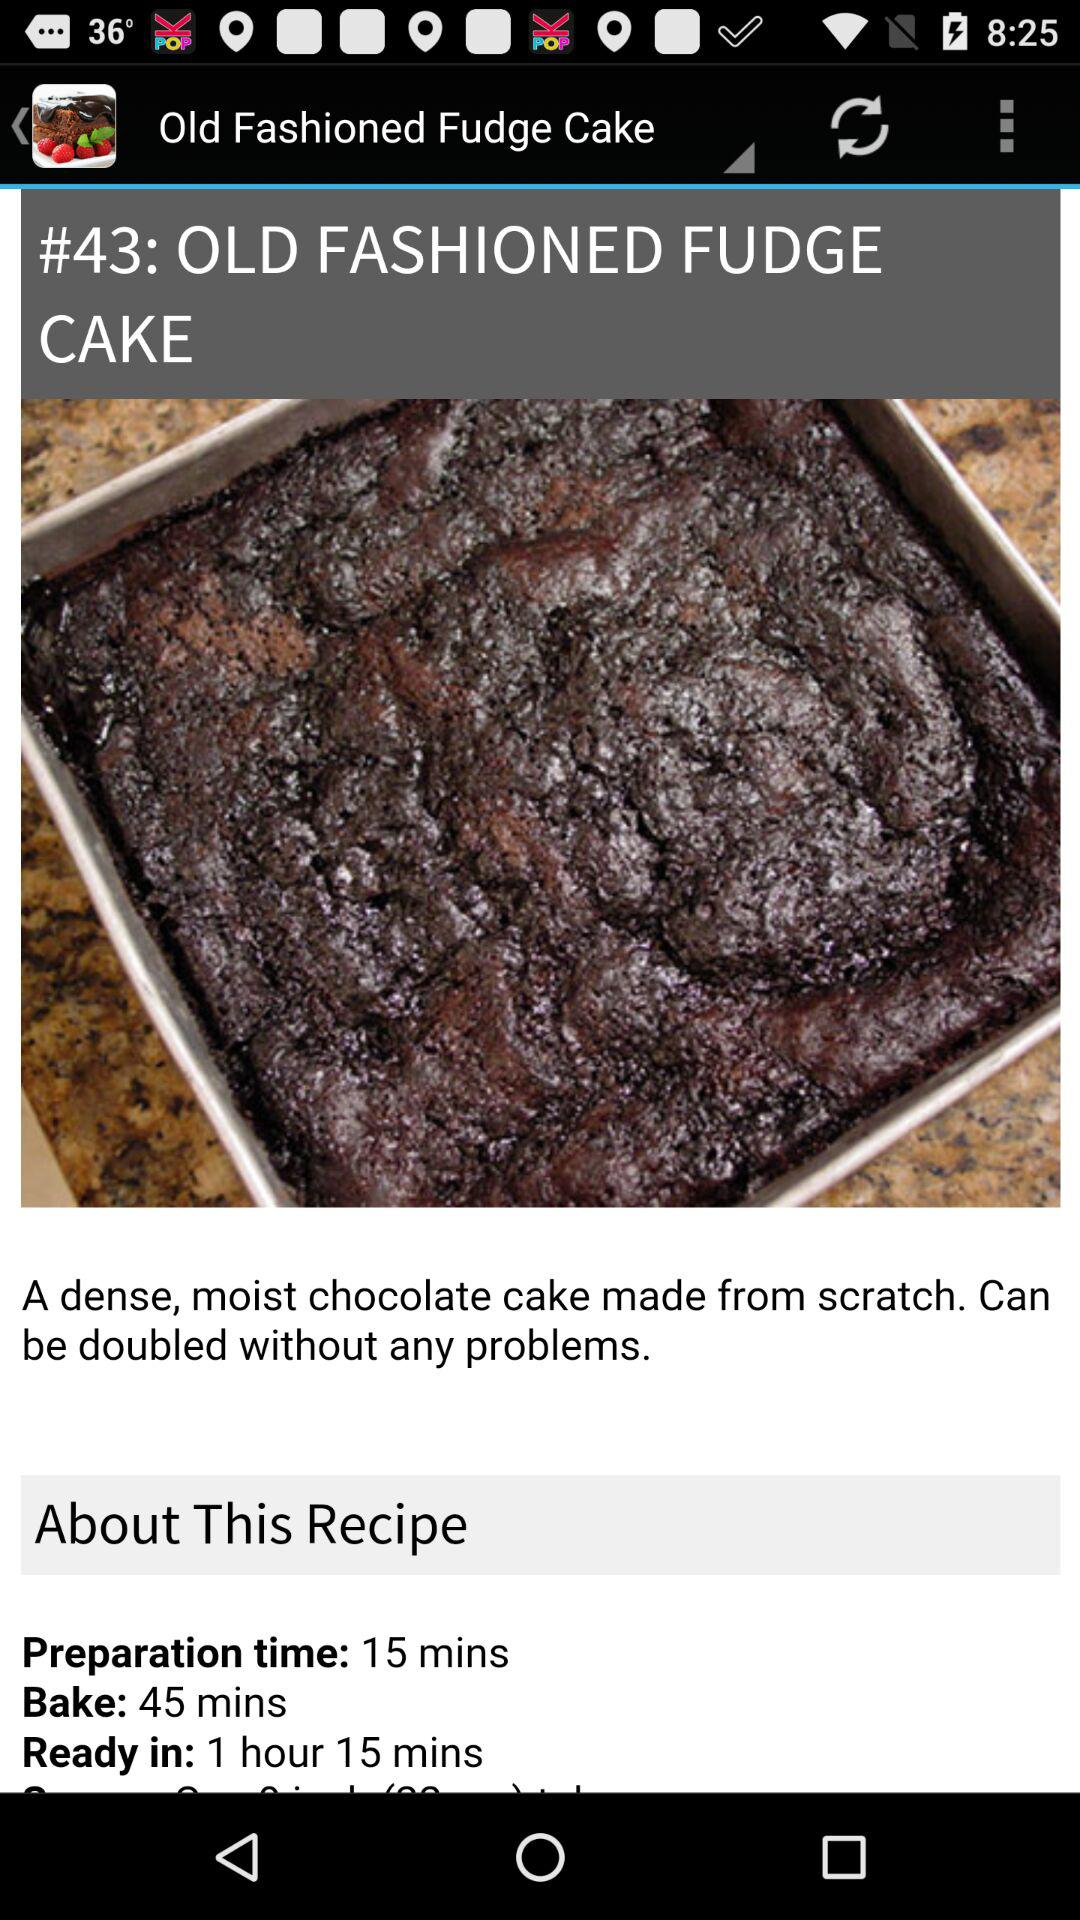How many calories are in 1 serving of "OLD FASHIONED FUDGE CAKE"?
When the provided information is insufficient, respond with <no answer>. <no answer> 